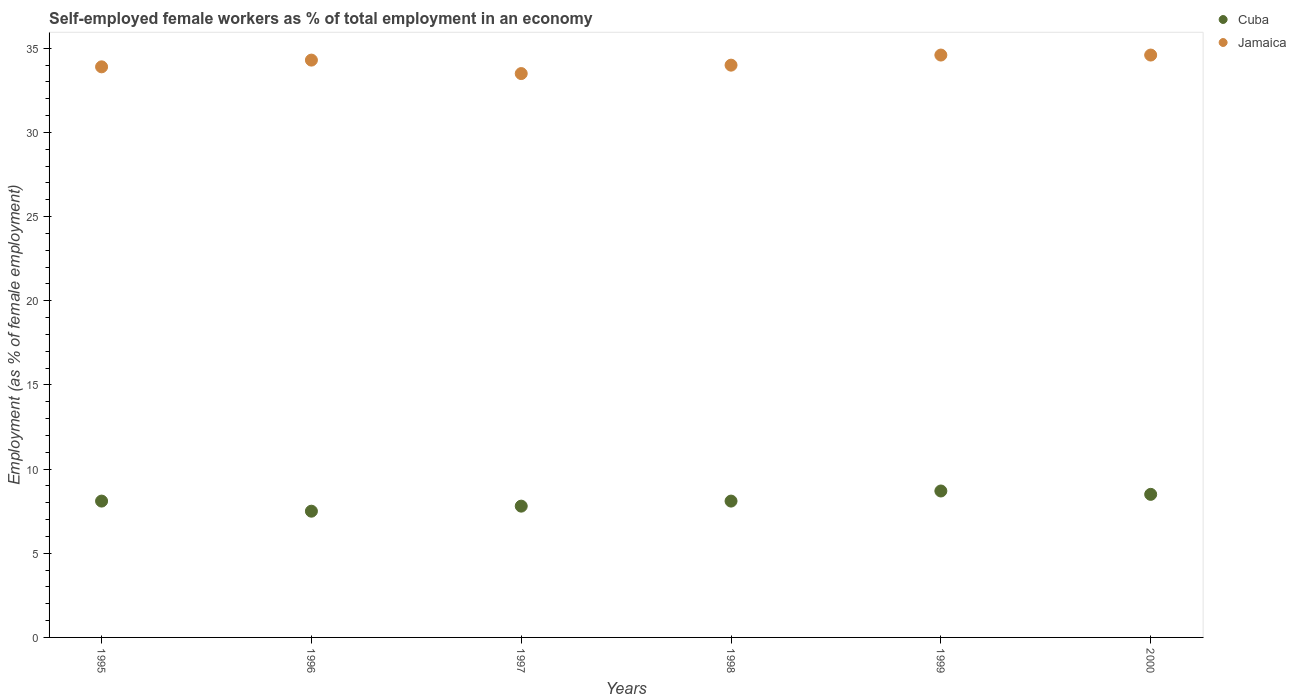What is the percentage of self-employed female workers in Jamaica in 2000?
Your answer should be very brief. 34.6. Across all years, what is the maximum percentage of self-employed female workers in Jamaica?
Make the answer very short. 34.6. In which year was the percentage of self-employed female workers in Jamaica maximum?
Your response must be concise. 1999. In which year was the percentage of self-employed female workers in Jamaica minimum?
Give a very brief answer. 1997. What is the total percentage of self-employed female workers in Jamaica in the graph?
Keep it short and to the point. 204.9. What is the difference between the percentage of self-employed female workers in Cuba in 1999 and that in 2000?
Keep it short and to the point. 0.2. What is the difference between the percentage of self-employed female workers in Cuba in 1997 and the percentage of self-employed female workers in Jamaica in 1996?
Your answer should be compact. -26.5. What is the average percentage of self-employed female workers in Jamaica per year?
Your response must be concise. 34.15. In the year 2000, what is the difference between the percentage of self-employed female workers in Cuba and percentage of self-employed female workers in Jamaica?
Your answer should be compact. -26.1. What is the ratio of the percentage of self-employed female workers in Cuba in 1995 to that in 1996?
Ensure brevity in your answer.  1.08. Is the difference between the percentage of self-employed female workers in Cuba in 1995 and 2000 greater than the difference between the percentage of self-employed female workers in Jamaica in 1995 and 2000?
Provide a succinct answer. Yes. What is the difference between the highest and the second highest percentage of self-employed female workers in Jamaica?
Provide a succinct answer. 0. What is the difference between the highest and the lowest percentage of self-employed female workers in Jamaica?
Provide a short and direct response. 1.1. In how many years, is the percentage of self-employed female workers in Jamaica greater than the average percentage of self-employed female workers in Jamaica taken over all years?
Provide a short and direct response. 3. Is the sum of the percentage of self-employed female workers in Cuba in 1995 and 2000 greater than the maximum percentage of self-employed female workers in Jamaica across all years?
Offer a very short reply. No. Does the percentage of self-employed female workers in Jamaica monotonically increase over the years?
Your response must be concise. No. How many dotlines are there?
Provide a short and direct response. 2. Are the values on the major ticks of Y-axis written in scientific E-notation?
Keep it short and to the point. No. Does the graph contain any zero values?
Provide a short and direct response. No. Where does the legend appear in the graph?
Ensure brevity in your answer.  Top right. How many legend labels are there?
Provide a short and direct response. 2. How are the legend labels stacked?
Your response must be concise. Vertical. What is the title of the graph?
Your answer should be compact. Self-employed female workers as % of total employment in an economy. Does "Middle income" appear as one of the legend labels in the graph?
Your answer should be very brief. No. What is the label or title of the Y-axis?
Ensure brevity in your answer.  Employment (as % of female employment). What is the Employment (as % of female employment) of Cuba in 1995?
Make the answer very short. 8.1. What is the Employment (as % of female employment) in Jamaica in 1995?
Give a very brief answer. 33.9. What is the Employment (as % of female employment) of Jamaica in 1996?
Ensure brevity in your answer.  34.3. What is the Employment (as % of female employment) of Cuba in 1997?
Keep it short and to the point. 7.8. What is the Employment (as % of female employment) of Jamaica in 1997?
Ensure brevity in your answer.  33.5. What is the Employment (as % of female employment) in Cuba in 1998?
Give a very brief answer. 8.1. What is the Employment (as % of female employment) in Jamaica in 1998?
Make the answer very short. 34. What is the Employment (as % of female employment) of Cuba in 1999?
Provide a short and direct response. 8.7. What is the Employment (as % of female employment) of Jamaica in 1999?
Provide a succinct answer. 34.6. What is the Employment (as % of female employment) in Cuba in 2000?
Give a very brief answer. 8.5. What is the Employment (as % of female employment) in Jamaica in 2000?
Make the answer very short. 34.6. Across all years, what is the maximum Employment (as % of female employment) in Cuba?
Ensure brevity in your answer.  8.7. Across all years, what is the maximum Employment (as % of female employment) of Jamaica?
Your response must be concise. 34.6. Across all years, what is the minimum Employment (as % of female employment) of Cuba?
Give a very brief answer. 7.5. Across all years, what is the minimum Employment (as % of female employment) in Jamaica?
Offer a very short reply. 33.5. What is the total Employment (as % of female employment) in Cuba in the graph?
Your answer should be very brief. 48.7. What is the total Employment (as % of female employment) in Jamaica in the graph?
Offer a very short reply. 204.9. What is the difference between the Employment (as % of female employment) in Cuba in 1995 and that in 1996?
Provide a succinct answer. 0.6. What is the difference between the Employment (as % of female employment) in Jamaica in 1995 and that in 1996?
Your answer should be compact. -0.4. What is the difference between the Employment (as % of female employment) in Jamaica in 1995 and that in 1997?
Your answer should be very brief. 0.4. What is the difference between the Employment (as % of female employment) in Cuba in 1995 and that in 1998?
Your response must be concise. 0. What is the difference between the Employment (as % of female employment) of Jamaica in 1995 and that in 1998?
Give a very brief answer. -0.1. What is the difference between the Employment (as % of female employment) of Jamaica in 1995 and that in 1999?
Offer a terse response. -0.7. What is the difference between the Employment (as % of female employment) in Jamaica in 1996 and that in 1997?
Give a very brief answer. 0.8. What is the difference between the Employment (as % of female employment) of Cuba in 1996 and that in 1999?
Offer a terse response. -1.2. What is the difference between the Employment (as % of female employment) in Jamaica in 1996 and that in 1999?
Offer a terse response. -0.3. What is the difference between the Employment (as % of female employment) of Cuba in 1997 and that in 2000?
Offer a terse response. -0.7. What is the difference between the Employment (as % of female employment) in Jamaica in 1997 and that in 2000?
Offer a terse response. -1.1. What is the difference between the Employment (as % of female employment) of Cuba in 1998 and that in 1999?
Give a very brief answer. -0.6. What is the difference between the Employment (as % of female employment) in Jamaica in 1998 and that in 1999?
Provide a succinct answer. -0.6. What is the difference between the Employment (as % of female employment) in Cuba in 1998 and that in 2000?
Keep it short and to the point. -0.4. What is the difference between the Employment (as % of female employment) of Jamaica in 1999 and that in 2000?
Your answer should be compact. 0. What is the difference between the Employment (as % of female employment) in Cuba in 1995 and the Employment (as % of female employment) in Jamaica in 1996?
Keep it short and to the point. -26.2. What is the difference between the Employment (as % of female employment) of Cuba in 1995 and the Employment (as % of female employment) of Jamaica in 1997?
Your response must be concise. -25.4. What is the difference between the Employment (as % of female employment) of Cuba in 1995 and the Employment (as % of female employment) of Jamaica in 1998?
Provide a short and direct response. -25.9. What is the difference between the Employment (as % of female employment) of Cuba in 1995 and the Employment (as % of female employment) of Jamaica in 1999?
Offer a very short reply. -26.5. What is the difference between the Employment (as % of female employment) in Cuba in 1995 and the Employment (as % of female employment) in Jamaica in 2000?
Provide a short and direct response. -26.5. What is the difference between the Employment (as % of female employment) in Cuba in 1996 and the Employment (as % of female employment) in Jamaica in 1997?
Offer a very short reply. -26. What is the difference between the Employment (as % of female employment) in Cuba in 1996 and the Employment (as % of female employment) in Jamaica in 1998?
Give a very brief answer. -26.5. What is the difference between the Employment (as % of female employment) in Cuba in 1996 and the Employment (as % of female employment) in Jamaica in 1999?
Ensure brevity in your answer.  -27.1. What is the difference between the Employment (as % of female employment) of Cuba in 1996 and the Employment (as % of female employment) of Jamaica in 2000?
Ensure brevity in your answer.  -27.1. What is the difference between the Employment (as % of female employment) of Cuba in 1997 and the Employment (as % of female employment) of Jamaica in 1998?
Keep it short and to the point. -26.2. What is the difference between the Employment (as % of female employment) of Cuba in 1997 and the Employment (as % of female employment) of Jamaica in 1999?
Give a very brief answer. -26.8. What is the difference between the Employment (as % of female employment) in Cuba in 1997 and the Employment (as % of female employment) in Jamaica in 2000?
Offer a very short reply. -26.8. What is the difference between the Employment (as % of female employment) of Cuba in 1998 and the Employment (as % of female employment) of Jamaica in 1999?
Ensure brevity in your answer.  -26.5. What is the difference between the Employment (as % of female employment) in Cuba in 1998 and the Employment (as % of female employment) in Jamaica in 2000?
Ensure brevity in your answer.  -26.5. What is the difference between the Employment (as % of female employment) in Cuba in 1999 and the Employment (as % of female employment) in Jamaica in 2000?
Give a very brief answer. -25.9. What is the average Employment (as % of female employment) of Cuba per year?
Your answer should be very brief. 8.12. What is the average Employment (as % of female employment) of Jamaica per year?
Provide a short and direct response. 34.15. In the year 1995, what is the difference between the Employment (as % of female employment) of Cuba and Employment (as % of female employment) of Jamaica?
Keep it short and to the point. -25.8. In the year 1996, what is the difference between the Employment (as % of female employment) of Cuba and Employment (as % of female employment) of Jamaica?
Keep it short and to the point. -26.8. In the year 1997, what is the difference between the Employment (as % of female employment) of Cuba and Employment (as % of female employment) of Jamaica?
Make the answer very short. -25.7. In the year 1998, what is the difference between the Employment (as % of female employment) of Cuba and Employment (as % of female employment) of Jamaica?
Your answer should be compact. -25.9. In the year 1999, what is the difference between the Employment (as % of female employment) of Cuba and Employment (as % of female employment) of Jamaica?
Your answer should be very brief. -25.9. In the year 2000, what is the difference between the Employment (as % of female employment) of Cuba and Employment (as % of female employment) of Jamaica?
Keep it short and to the point. -26.1. What is the ratio of the Employment (as % of female employment) of Cuba in 1995 to that in 1996?
Ensure brevity in your answer.  1.08. What is the ratio of the Employment (as % of female employment) in Jamaica in 1995 to that in 1996?
Provide a short and direct response. 0.99. What is the ratio of the Employment (as % of female employment) in Cuba in 1995 to that in 1997?
Offer a terse response. 1.04. What is the ratio of the Employment (as % of female employment) in Jamaica in 1995 to that in 1997?
Your response must be concise. 1.01. What is the ratio of the Employment (as % of female employment) of Cuba in 1995 to that in 1999?
Make the answer very short. 0.93. What is the ratio of the Employment (as % of female employment) in Jamaica in 1995 to that in 1999?
Your answer should be very brief. 0.98. What is the ratio of the Employment (as % of female employment) in Cuba in 1995 to that in 2000?
Offer a very short reply. 0.95. What is the ratio of the Employment (as % of female employment) of Jamaica in 1995 to that in 2000?
Make the answer very short. 0.98. What is the ratio of the Employment (as % of female employment) of Cuba in 1996 to that in 1997?
Make the answer very short. 0.96. What is the ratio of the Employment (as % of female employment) of Jamaica in 1996 to that in 1997?
Your answer should be compact. 1.02. What is the ratio of the Employment (as % of female employment) in Cuba in 1996 to that in 1998?
Ensure brevity in your answer.  0.93. What is the ratio of the Employment (as % of female employment) in Jamaica in 1996 to that in 1998?
Make the answer very short. 1.01. What is the ratio of the Employment (as % of female employment) of Cuba in 1996 to that in 1999?
Give a very brief answer. 0.86. What is the ratio of the Employment (as % of female employment) of Jamaica in 1996 to that in 1999?
Your answer should be very brief. 0.99. What is the ratio of the Employment (as % of female employment) of Cuba in 1996 to that in 2000?
Offer a terse response. 0.88. What is the ratio of the Employment (as % of female employment) of Jamaica in 1997 to that in 1998?
Your response must be concise. 0.99. What is the ratio of the Employment (as % of female employment) in Cuba in 1997 to that in 1999?
Offer a very short reply. 0.9. What is the ratio of the Employment (as % of female employment) of Jamaica in 1997 to that in 1999?
Give a very brief answer. 0.97. What is the ratio of the Employment (as % of female employment) of Cuba in 1997 to that in 2000?
Make the answer very short. 0.92. What is the ratio of the Employment (as % of female employment) of Jamaica in 1997 to that in 2000?
Keep it short and to the point. 0.97. What is the ratio of the Employment (as % of female employment) of Jamaica in 1998 to that in 1999?
Your answer should be compact. 0.98. What is the ratio of the Employment (as % of female employment) of Cuba in 1998 to that in 2000?
Offer a terse response. 0.95. What is the ratio of the Employment (as % of female employment) of Jamaica in 1998 to that in 2000?
Your answer should be very brief. 0.98. What is the ratio of the Employment (as % of female employment) in Cuba in 1999 to that in 2000?
Your response must be concise. 1.02. What is the difference between the highest and the second highest Employment (as % of female employment) in Cuba?
Make the answer very short. 0.2. What is the difference between the highest and the second highest Employment (as % of female employment) in Jamaica?
Provide a short and direct response. 0. What is the difference between the highest and the lowest Employment (as % of female employment) in Jamaica?
Keep it short and to the point. 1.1. 